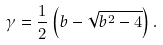<formula> <loc_0><loc_0><loc_500><loc_500>\gamma = \frac { 1 } { 2 } \left ( b - \sqrt { b ^ { 2 } - 4 } \right ) .</formula> 